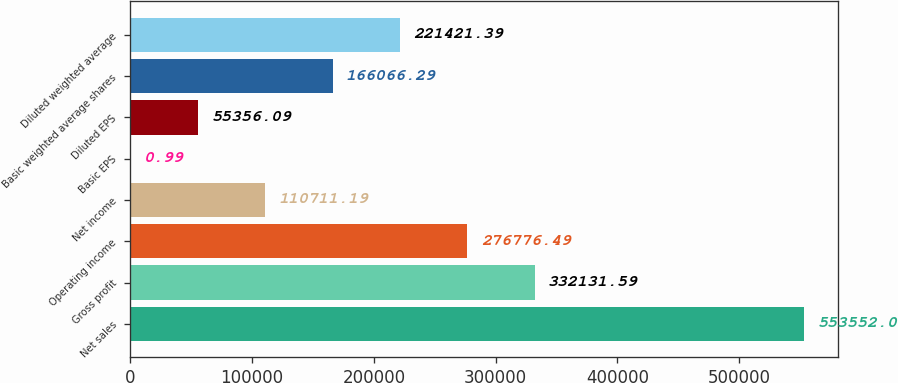Convert chart. <chart><loc_0><loc_0><loc_500><loc_500><bar_chart><fcel>Net sales<fcel>Gross profit<fcel>Operating income<fcel>Net income<fcel>Basic EPS<fcel>Diluted EPS<fcel>Basic weighted average shares<fcel>Diluted weighted average<nl><fcel>553552<fcel>332132<fcel>276776<fcel>110711<fcel>0.99<fcel>55356.1<fcel>166066<fcel>221421<nl></chart> 